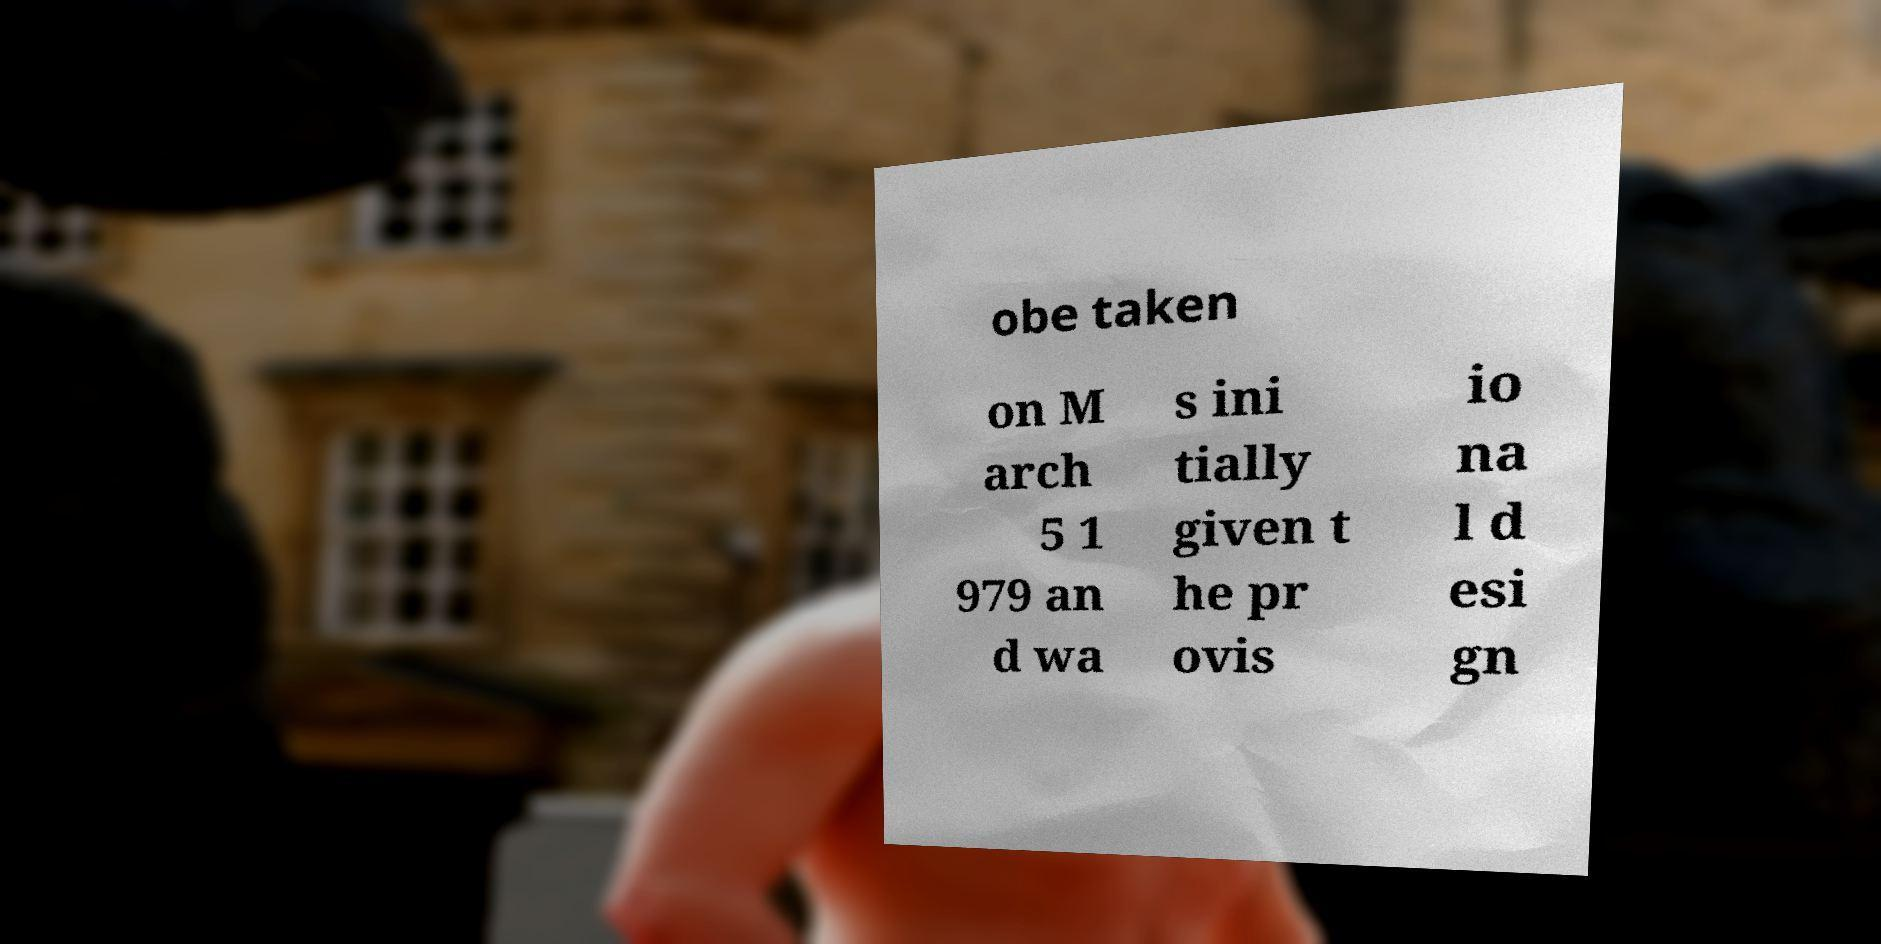Can you accurately transcribe the text from the provided image for me? obe taken on M arch 5 1 979 an d wa s ini tially given t he pr ovis io na l d esi gn 